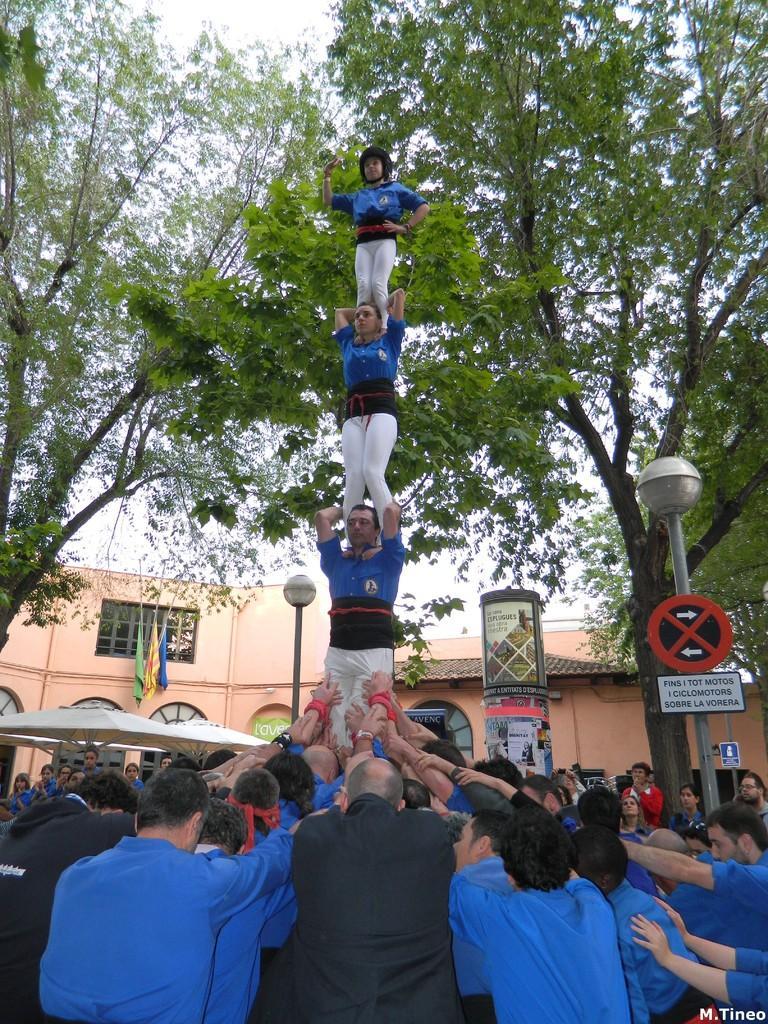In one or two sentences, can you explain what this image depicts? In this image there are persons, there are boards with some text written on it, there is a tent, there are poles, flags, trees and there is a building and at the bottom right of the image there is some text which is visible. 